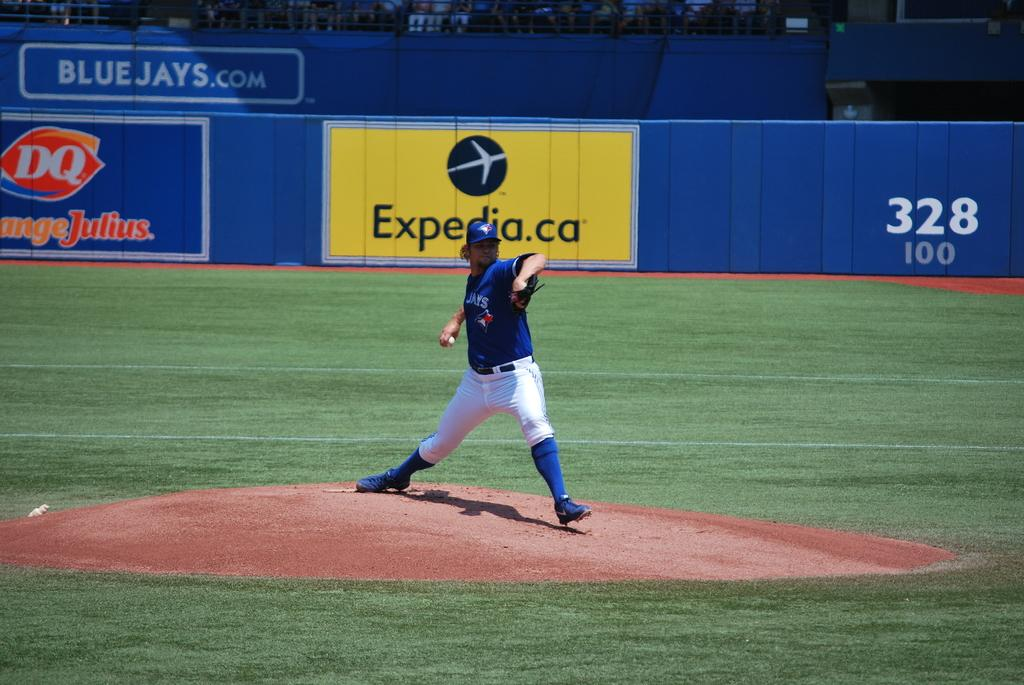<image>
Render a clear and concise summary of the photo. some players playing baseball with the name expedia on a sign 